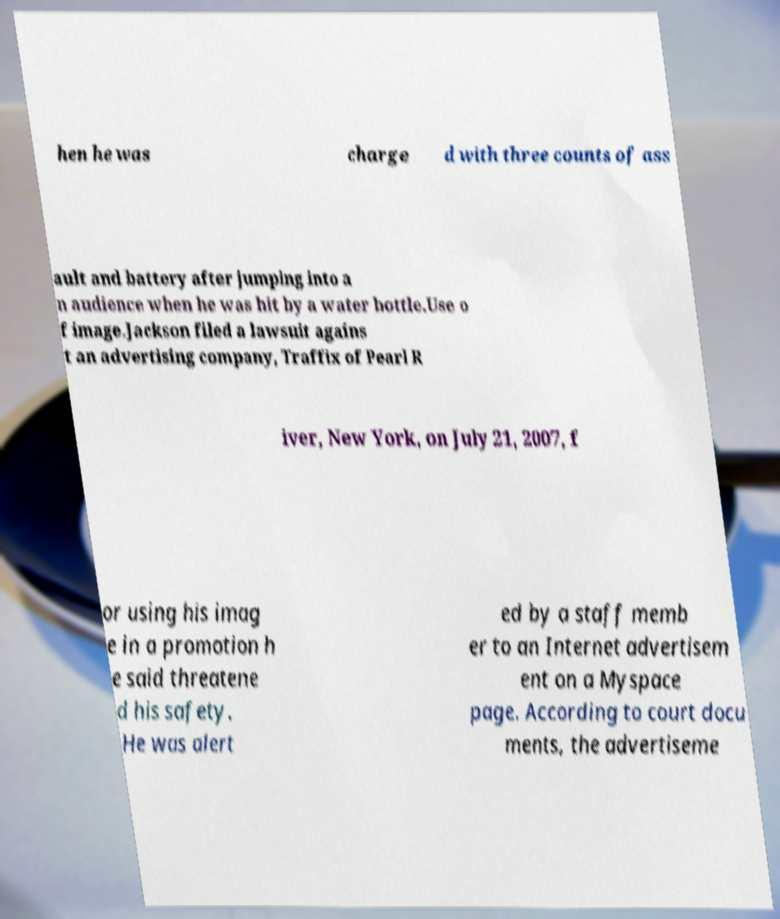Can you read and provide the text displayed in the image?This photo seems to have some interesting text. Can you extract and type it out for me? hen he was charge d with three counts of ass ault and battery after jumping into a n audience when he was hit by a water bottle.Use o f image.Jackson filed a lawsuit agains t an advertising company, Traffix of Pearl R iver, New York, on July 21, 2007, f or using his imag e in a promotion h e said threatene d his safety. He was alert ed by a staff memb er to an Internet advertisem ent on a Myspace page. According to court docu ments, the advertiseme 